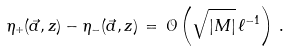<formula> <loc_0><loc_0><loc_500><loc_500>\eta _ { + } ( \vec { a } , z ) - \eta _ { - } ( \vec { a } , z ) \, = \, \mathcal { O } \left ( \sqrt { | M | } \, \ell ^ { - 1 } \right ) \, .</formula> 